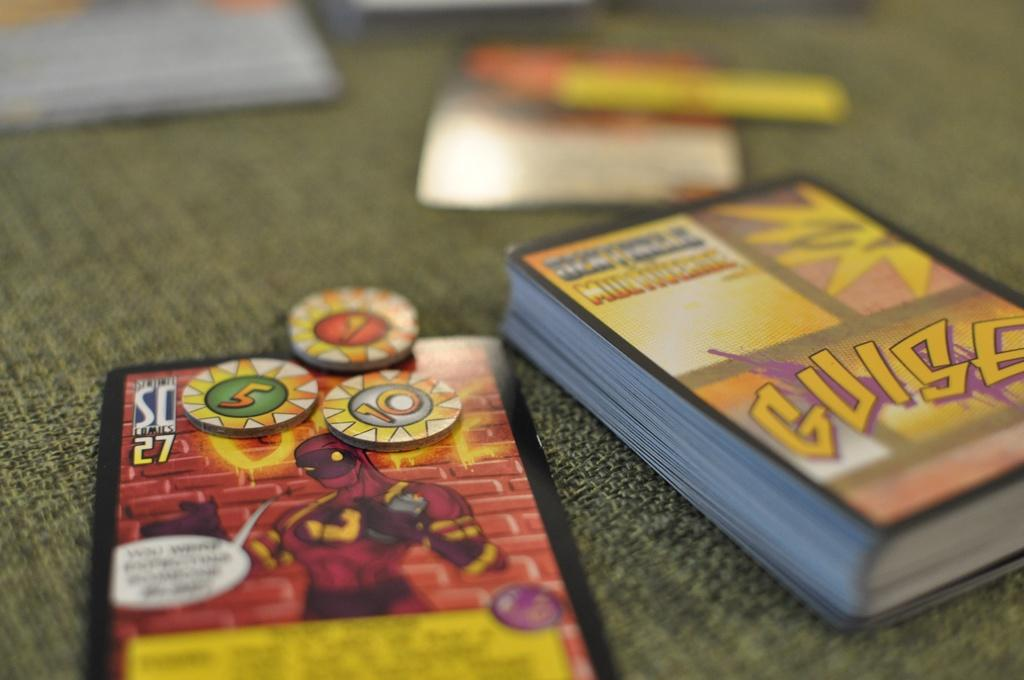Provide a one-sentence caption for the provided image. A stack of Yugioh cards with toy coins on top. 